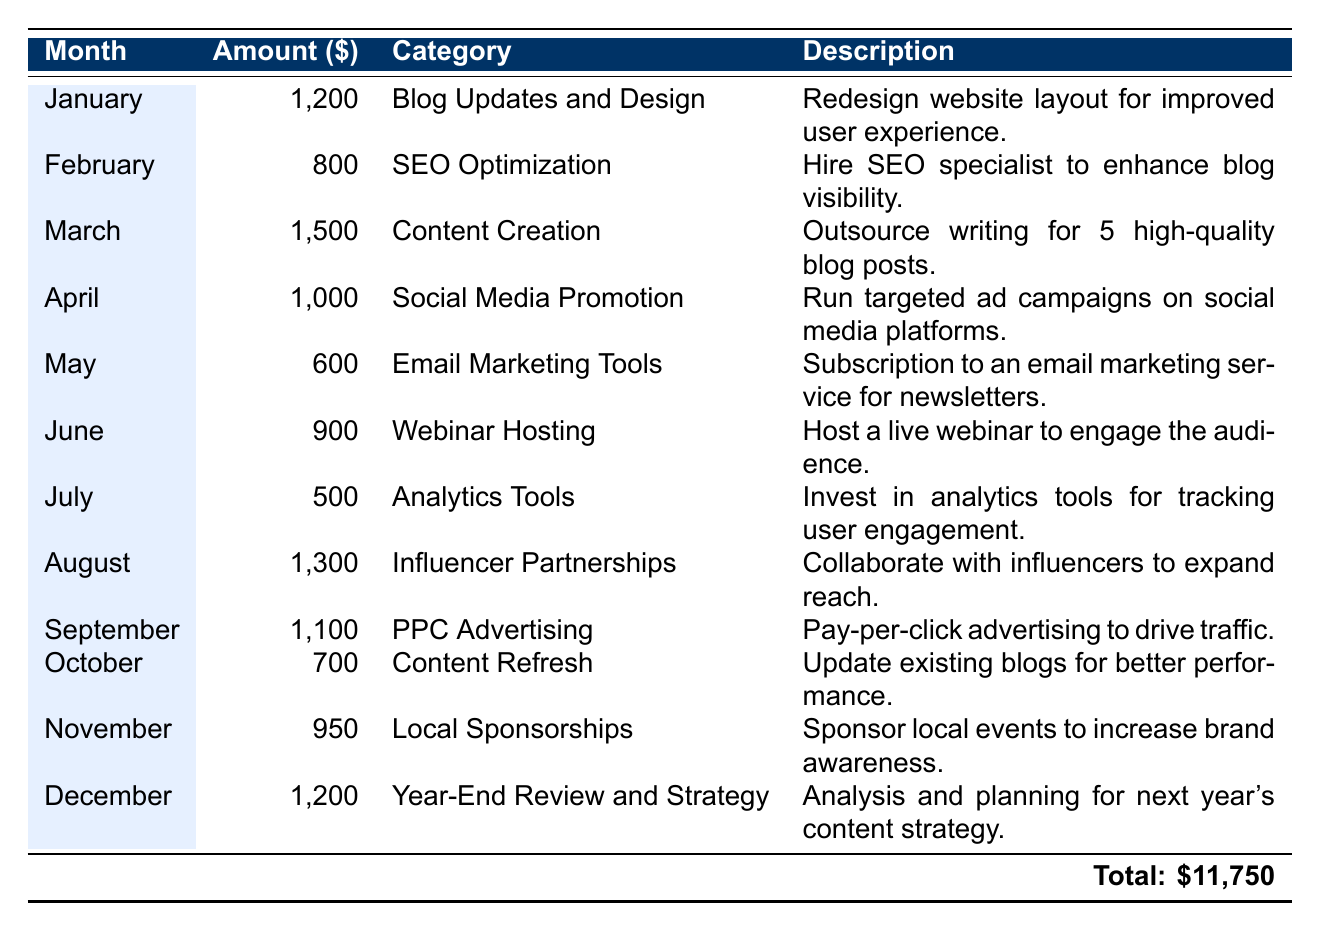What is the total amount spent on content marketing expenses over the 12 months? The total amount is provided in the table under the last row, indicating that all individual expenses were summed up to reach this value. The total is \$11,750.
Answer: 11,750 Which month had the highest expense and what was the category? We can look through the amounts listed for each month and compare them. The highest expense is \$1,500 in March for the category "Content Creation."
Answer: March, Content Creation How much was spent on Social Media Promotion? From the table, we see that the amount listed for Social Media Promotion in April is \$1,000.
Answer: 1,000 What is the average monthly expense for the year? To find the average, we sum up all expenses (\$11,750) and divide by the number of months (12). Thus, \$11,750 / 12 = approximately \$979.17.
Answer: 979.17 Did the expenses for August exceed those for July? By checking the values, August's expense is \$1,300 and July's is \$500; since \$1,300 is greater than \$500, the answer is yes.
Answer: Yes What is the total spent on categories related to advertising (PPC Advertising and influencer partnerships)? We identify the amounts for both categories: \$1,100 for PPC Advertising and \$1,300 for Influencer Partnerships. The total is \$1,100 + \$1,300 = \$2,400.
Answer: 2,400 Which category had the lowest expense? On examination of the table, the amount for Analytics Tools in July is \$500, which is the lowest expense shown across all months.
Answer: Analytics Tools Overall, how many expenses were below \$1,000? We count the rows where expenses are less than \$1,000. The relevant months are May (\$600), July (\$500), and October (\$700). This comes to a total of 3 months.
Answer: 3 What was the expense for Year-End Review and Strategy in December? The table specifies the expense for December as \$1,200, which can be directly referenced.
Answer: 1,200 